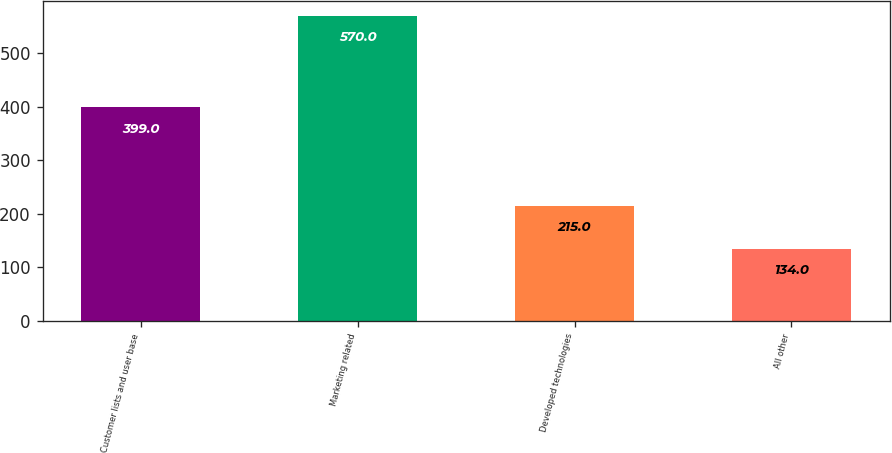Convert chart to OTSL. <chart><loc_0><loc_0><loc_500><loc_500><bar_chart><fcel>Customer lists and user base<fcel>Marketing related<fcel>Developed technologies<fcel>All other<nl><fcel>399<fcel>570<fcel>215<fcel>134<nl></chart> 